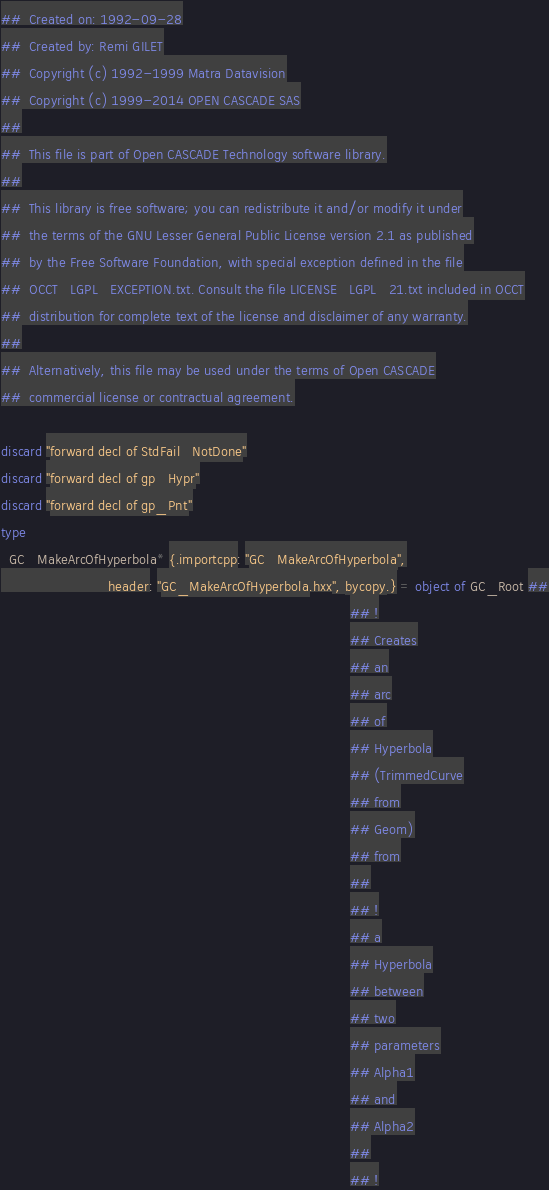<code> <loc_0><loc_0><loc_500><loc_500><_Nim_>##  Created on: 1992-09-28
##  Created by: Remi GILET
##  Copyright (c) 1992-1999 Matra Datavision
##  Copyright (c) 1999-2014 OPEN CASCADE SAS
##
##  This file is part of Open CASCADE Technology software library.
##
##  This library is free software; you can redistribute it and/or modify it under
##  the terms of the GNU Lesser General Public License version 2.1 as published
##  by the Free Software Foundation, with special exception defined in the file
##  OCCT_LGPL_EXCEPTION.txt. Consult the file LICENSE_LGPL_21.txt included in OCCT
##  distribution for complete text of the license and disclaimer of any warranty.
##
##  Alternatively, this file may be used under the terms of Open CASCADE
##  commercial license or contractual agreement.

discard "forward decl of StdFail_NotDone"
discard "forward decl of gp_Hypr"
discard "forward decl of gp_Pnt"
type
  GC_MakeArcOfHyperbola* {.importcpp: "GC_MakeArcOfHyperbola",
                          header: "GC_MakeArcOfHyperbola.hxx", bycopy.} = object of GC_Root ##
                                                                                     ## !
                                                                                     ## Creates
                                                                                     ## an
                                                                                     ## arc
                                                                                     ## of
                                                                                     ## Hyperbola
                                                                                     ## (TrimmedCurve
                                                                                     ## from
                                                                                     ## Geom)
                                                                                     ## from
                                                                                     ##
                                                                                     ## !
                                                                                     ## a
                                                                                     ## Hyperbola
                                                                                     ## between
                                                                                     ## two
                                                                                     ## parameters
                                                                                     ## Alpha1
                                                                                     ## and
                                                                                     ## Alpha2
                                                                                     ##
                                                                                     ## !</code> 